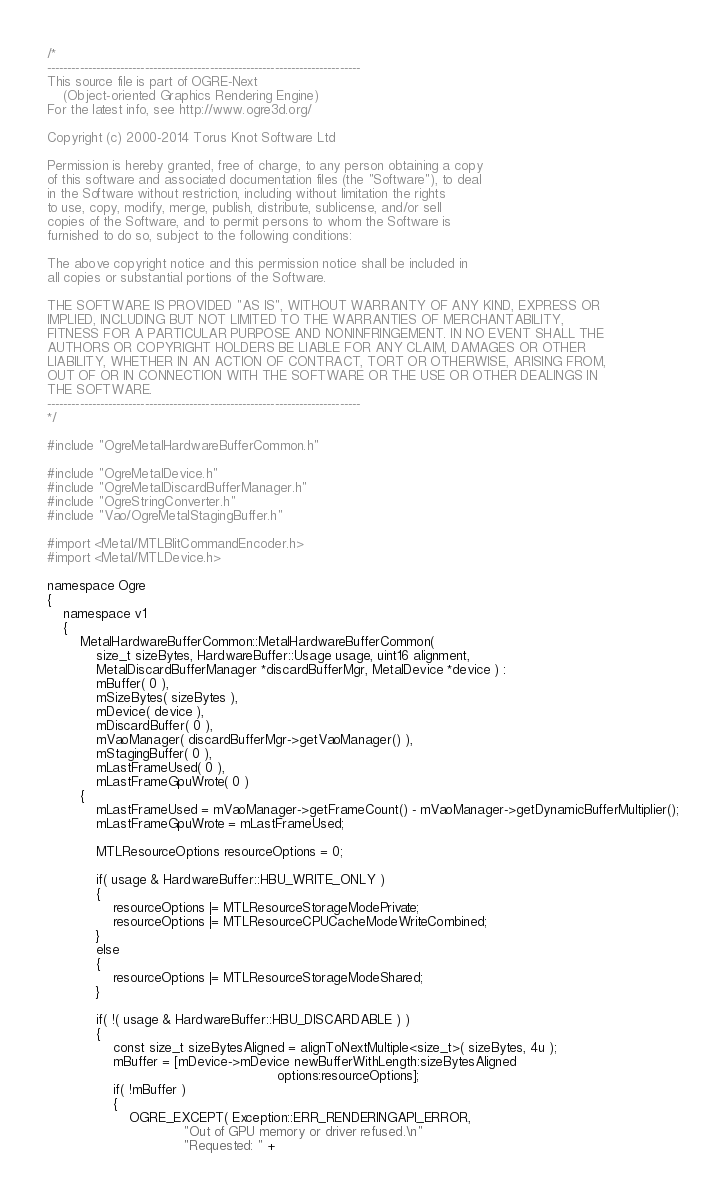Convert code to text. <code><loc_0><loc_0><loc_500><loc_500><_ObjectiveC_>/*
-----------------------------------------------------------------------------
This source file is part of OGRE-Next
    (Object-oriented Graphics Rendering Engine)
For the latest info, see http://www.ogre3d.org/

Copyright (c) 2000-2014 Torus Knot Software Ltd

Permission is hereby granted, free of charge, to any person obtaining a copy
of this software and associated documentation files (the "Software"), to deal
in the Software without restriction, including without limitation the rights
to use, copy, modify, merge, publish, distribute, sublicense, and/or sell
copies of the Software, and to permit persons to whom the Software is
furnished to do so, subject to the following conditions:

The above copyright notice and this permission notice shall be included in
all copies or substantial portions of the Software.

THE SOFTWARE IS PROVIDED "AS IS", WITHOUT WARRANTY OF ANY KIND, EXPRESS OR
IMPLIED, INCLUDING BUT NOT LIMITED TO THE WARRANTIES OF MERCHANTABILITY,
FITNESS FOR A PARTICULAR PURPOSE AND NONINFRINGEMENT. IN NO EVENT SHALL THE
AUTHORS OR COPYRIGHT HOLDERS BE LIABLE FOR ANY CLAIM, DAMAGES OR OTHER
LIABILITY, WHETHER IN AN ACTION OF CONTRACT, TORT OR OTHERWISE, ARISING FROM,
OUT OF OR IN CONNECTION WITH THE SOFTWARE OR THE USE OR OTHER DEALINGS IN
THE SOFTWARE.
-----------------------------------------------------------------------------
*/

#include "OgreMetalHardwareBufferCommon.h"

#include "OgreMetalDevice.h"
#include "OgreMetalDiscardBufferManager.h"
#include "OgreStringConverter.h"
#include "Vao/OgreMetalStagingBuffer.h"

#import <Metal/MTLBlitCommandEncoder.h>
#import <Metal/MTLDevice.h>

namespace Ogre
{
    namespace v1
    {
        MetalHardwareBufferCommon::MetalHardwareBufferCommon(
            size_t sizeBytes, HardwareBuffer::Usage usage, uint16 alignment,
            MetalDiscardBufferManager *discardBufferMgr, MetalDevice *device ) :
            mBuffer( 0 ),
            mSizeBytes( sizeBytes ),
            mDevice( device ),
            mDiscardBuffer( 0 ),
            mVaoManager( discardBufferMgr->getVaoManager() ),
            mStagingBuffer( 0 ),
            mLastFrameUsed( 0 ),
            mLastFrameGpuWrote( 0 )
        {
            mLastFrameUsed = mVaoManager->getFrameCount() - mVaoManager->getDynamicBufferMultiplier();
            mLastFrameGpuWrote = mLastFrameUsed;

            MTLResourceOptions resourceOptions = 0;

            if( usage & HardwareBuffer::HBU_WRITE_ONLY )
            {
                resourceOptions |= MTLResourceStorageModePrivate;
                resourceOptions |= MTLResourceCPUCacheModeWriteCombined;
            }
            else
            {
                resourceOptions |= MTLResourceStorageModeShared;
            }

            if( !( usage & HardwareBuffer::HBU_DISCARDABLE ) )
            {
                const size_t sizeBytesAligned = alignToNextMultiple<size_t>( sizeBytes, 4u );
                mBuffer = [mDevice->mDevice newBufferWithLength:sizeBytesAligned
                                                        options:resourceOptions];
                if( !mBuffer )
                {
                    OGRE_EXCEPT( Exception::ERR_RENDERINGAPI_ERROR,
                                 "Out of GPU memory or driver refused.\n"
                                 "Requested: " +</code> 